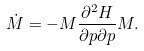Convert formula to latex. <formula><loc_0><loc_0><loc_500><loc_500>\dot { M } = - { M } \frac { \partial ^ { 2 } H } { \partial p \partial p } { M } .</formula> 